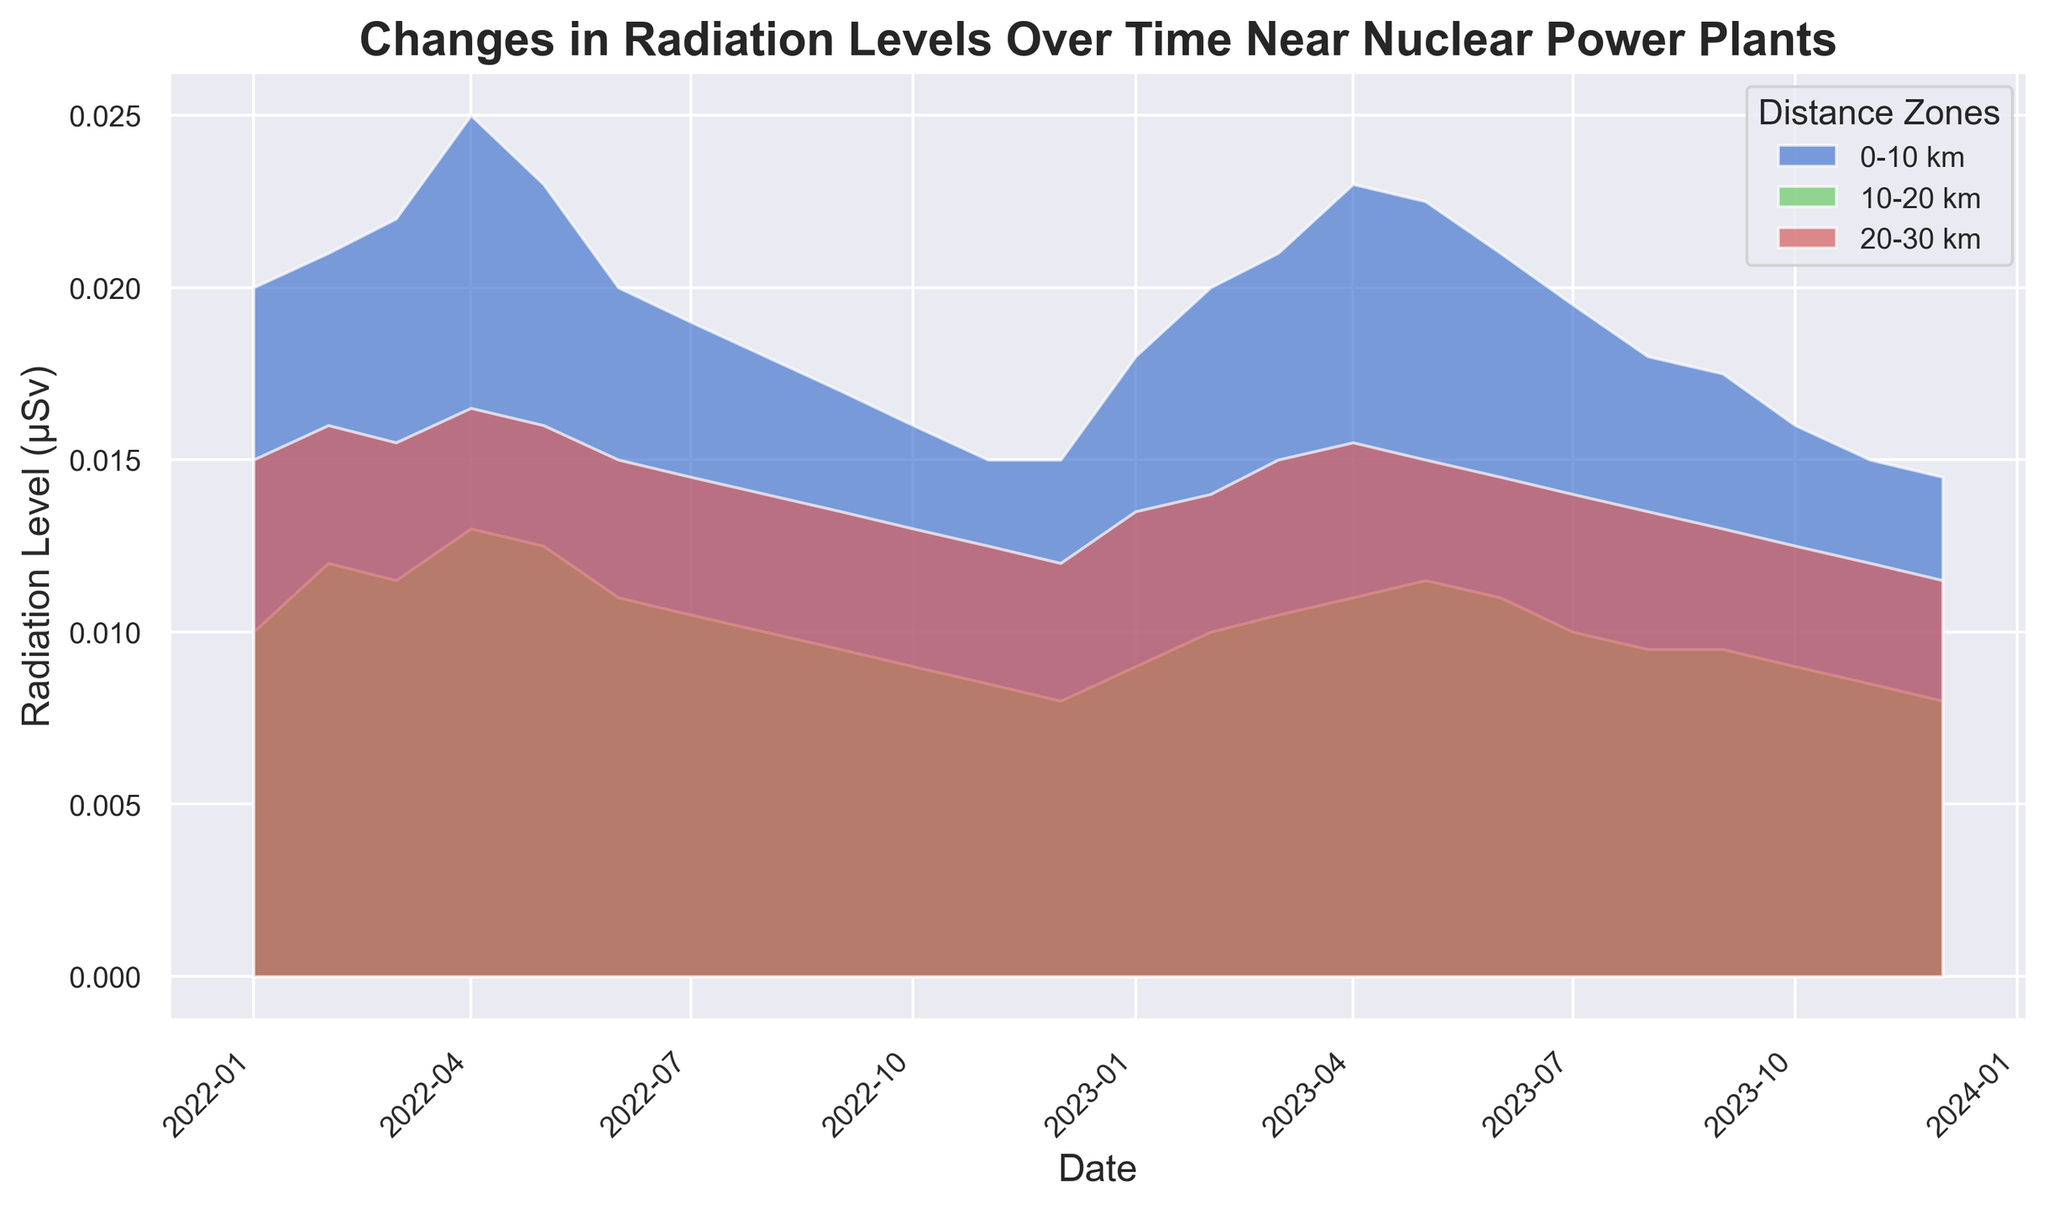What is the general trend of radiation levels in the 0-10 km zone from January 2022 to December 2023? To determine the general trend, observe the starting and ending points and the general shape of the area chart. The radiation level in the 0-10 km zone starts higher in January 2022, decreases towards November 2022, slightly fluctuates, and then further decreases towards December 2023.
Answer: Decreasing trend How do the radiation levels in the 0-10 km zone in January 2022 compare to those in December 2023? Locate the radiation levels for the 0-10 km zone on the y-axis for January 2022 and December 2023. In January 2022, the level is around 0.02 μSv, while in December 2023, it has decreased to around 0.0145 μSv.
Answer: January 2022 has higher levels Which distance zone shows the least variation in radiation levels over the given period? Observe the three zones and see which one has the least fluctuation in its area. The 20-30 km zone has the least variation compared to the other zones, as its range is more stable.
Answer: 20-30 km zone What is the average radiation level in the 10-20 km zone for the year 2022? Sum up the radiation levels for all months in 2022 for the 10-20 km zone and then divide by the number of months (12). (0.01 + 0.012 + 0.0115 + 0.013 + 0.0125 + 0.011 + 0.0105 + 0.01 + 0.0095 + 0.009 + 0.0085 + 0.008)/12 = 0.01054167 μSv (approx).
Answer: 0.0105 μSv Comparing the peaks, which month had the highest radiation level in the 0-10 km zone, and what was the value? Identify the highest area peak within the 0-10 km zone. April 2022 had the highest peak in the 0-10 km zone with a value of 0.025 μSv.
Answer: April 2022, 0.025 μSv What is the difference in radiation levels between the 0-10 km zone and the 20-30 km zone in April 2022? Find the radiation levels for both zones in April 2022 and compute the difference: 0.025 μSv (0-10 km) - 0.0165 μSv (20-30 km) = 0.0085 μSv.
Answer: 0.0085 μSv Which month saw the steepest decline in radiation levels in the 10-20 km zone, and what was the value of the decline? Look for the sharpest drop in the area for the 10-20 km zone. The steepest decline occurred between April 2022 (0.013 μSv) and May 2022 (0.0125 μSv), which is a drop of 0.0005 μSv.
Answer: May 2022, 0.0005 μSv How does the radiation level trend in the 10-20 km zone generally compare to the 20-30 km zone over the entire period? Observe the patterns of both zones. The 10-20 km zone generally follows a decreasing trend, with some minor fluctuations, similar to the more stable, decreasing trend in the 20-30 km zone.
Answer: Similar decreasing trend What was the highest combined radiation level across all distance zones in any single month in 2023, and which month was it? Sum the levels for all zones each month in 2023 and identify the highest sum. The highest combined level occurs in April 2023: (0.023 + 0.011 + 0.0155) μSv = 0.0495 μSv.
Answer: April 2023, 0.0495 μSv 